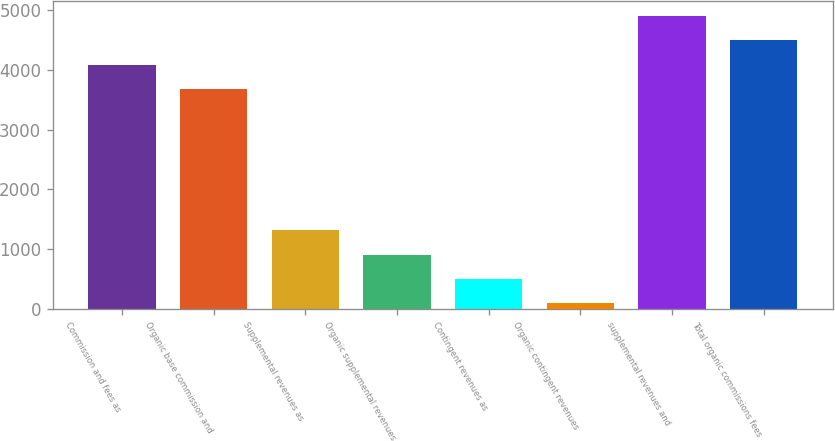Convert chart to OTSL. <chart><loc_0><loc_0><loc_500><loc_500><bar_chart><fcel>Commission and fees as<fcel>Organic base commission and<fcel>Supplemental revenues as<fcel>Organic supplemental revenues<fcel>Contingent revenues as<fcel>Organic contingent revenues<fcel>supplemental revenues and<fcel>Total organic commissions fees<nl><fcel>4086.21<fcel>3678.8<fcel>1315.23<fcel>907.82<fcel>500.41<fcel>93<fcel>4901.03<fcel>4493.62<nl></chart> 